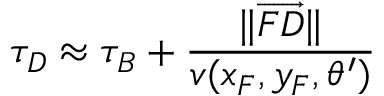Convert formula to latex. <formula><loc_0><loc_0><loc_500><loc_500>\tau _ { D } \approx \tau _ { B } + \frac { \| \overrightarrow { F D } \| } { v ( x _ { F } , y _ { F } , \theta ^ { \prime } ) }</formula> 